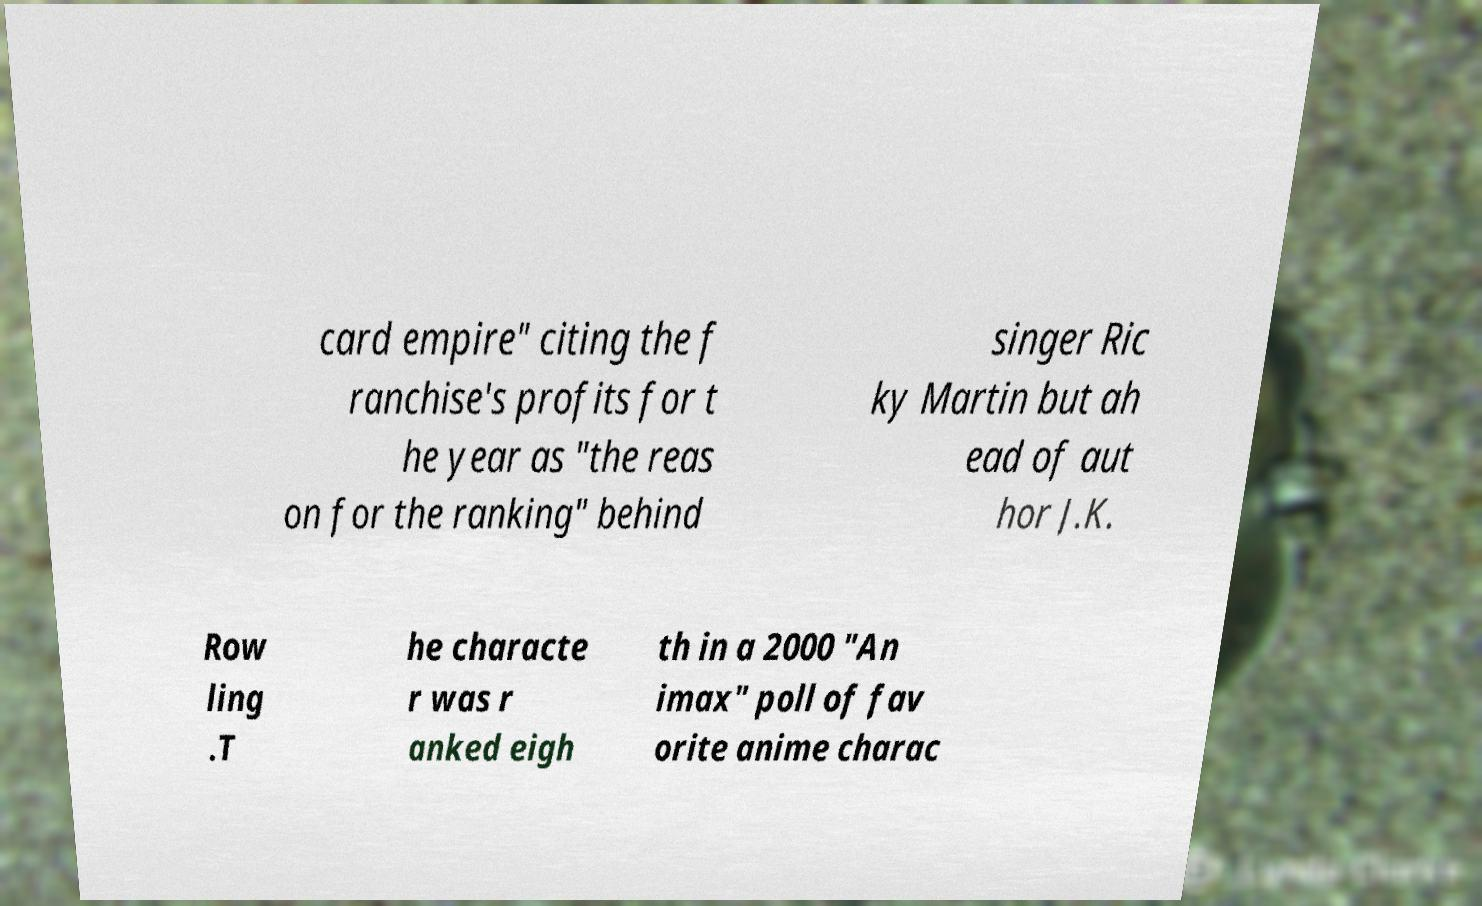Can you read and provide the text displayed in the image?This photo seems to have some interesting text. Can you extract and type it out for me? card empire" citing the f ranchise's profits for t he year as "the reas on for the ranking" behind singer Ric ky Martin but ah ead of aut hor J.K. Row ling .T he characte r was r anked eigh th in a 2000 "An imax" poll of fav orite anime charac 